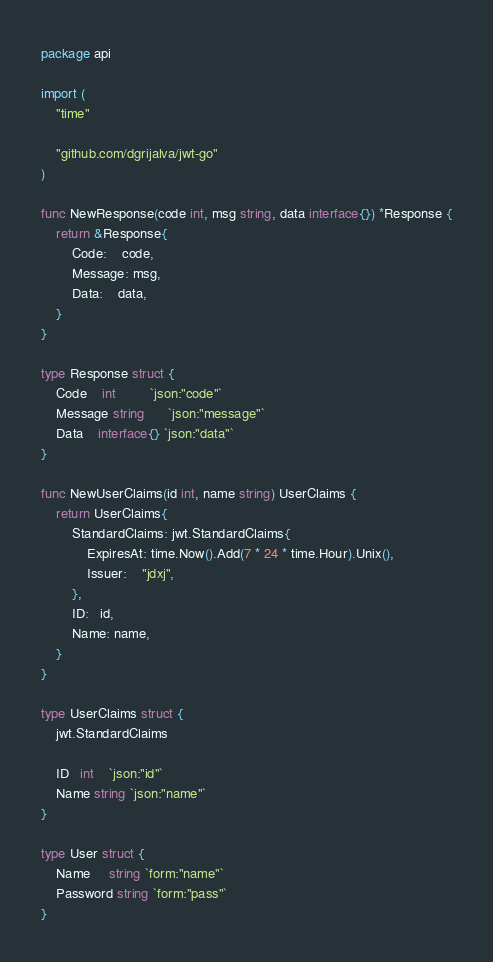<code> <loc_0><loc_0><loc_500><loc_500><_Go_>package api

import (
	"time"

	"github.com/dgrijalva/jwt-go"
)

func NewResponse(code int, msg string, data interface{}) *Response {
	return &Response{
		Code:    code,
		Message: msg,
		Data:    data,
	}
}

type Response struct {
	Code    int         `json:"code"`
	Message string      `json:"message"`
	Data    interface{} `json:"data"`
}

func NewUserClaims(id int, name string) UserClaims {
	return UserClaims{
		StandardClaims: jwt.StandardClaims{
			ExpiresAt: time.Now().Add(7 * 24 * time.Hour).Unix(),
			Issuer:    "jdxj",
		},
		ID:   id,
		Name: name,
	}
}

type UserClaims struct {
	jwt.StandardClaims

	ID   int    `json:"id"`
	Name string `json:"name"`
}

type User struct {
	Name     string `form:"name"`
	Password string `form:"pass"`
}
</code> 